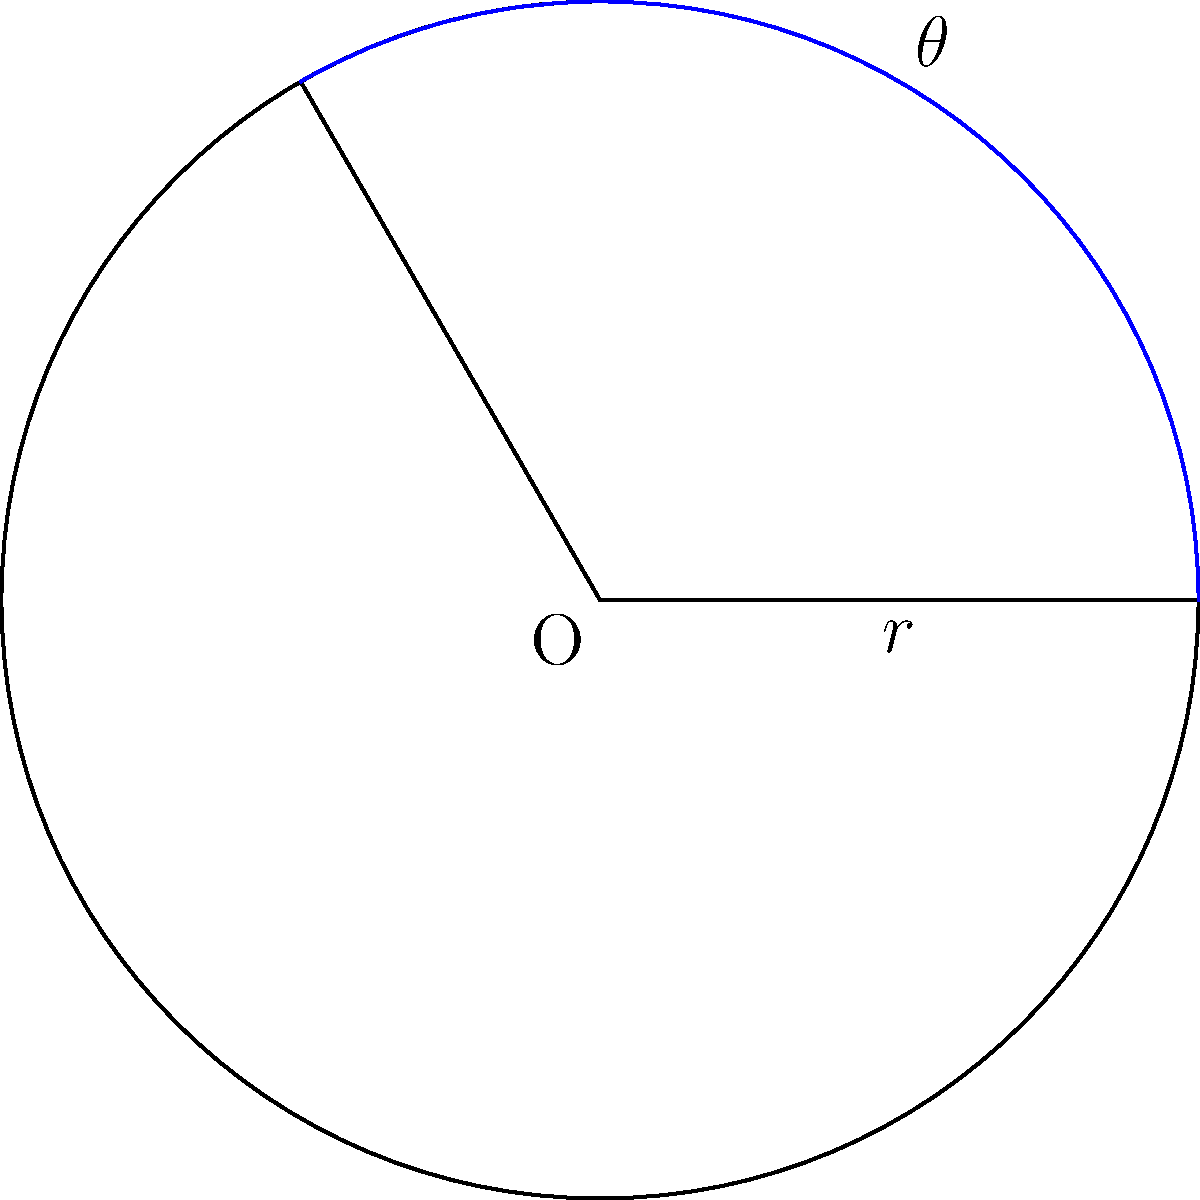Given a circular sector with radius $r = 5$ cm and central angle $\theta = 120°$, calculate its area. Round your answer to two decimal places. To calculate the area of a circular sector, we can follow these steps:

1) The formula for the area of a circular sector is:

   $$A = \frac{1}{2}r^2\theta$$

   Where $A$ is the area, $r$ is the radius, and $\theta$ is the central angle in radians.

2) We're given $r = 5$ cm and $\theta = 120°$. However, we need to convert the angle to radians:

   $$\theta_{rad} = 120° \times \frac{\pi}{180°} = \frac{2\pi}{3} \approx 2.0944$$

3) Now we can substitute these values into our formula:

   $$A = \frac{1}{2} \times 5^2 \times \frac{2\pi}{3}$$

4) Let's calculate step by step:
   
   $$A = \frac{1}{2} \times 25 \times \frac{2\pi}{3}$$
   $$A = \frac{25\pi}{3} \approx 26.1799$$

5) Rounding to two decimal places:

   $$A \approx 26.18\text{ cm}^2$$
Answer: $26.18\text{ cm}^2$ 